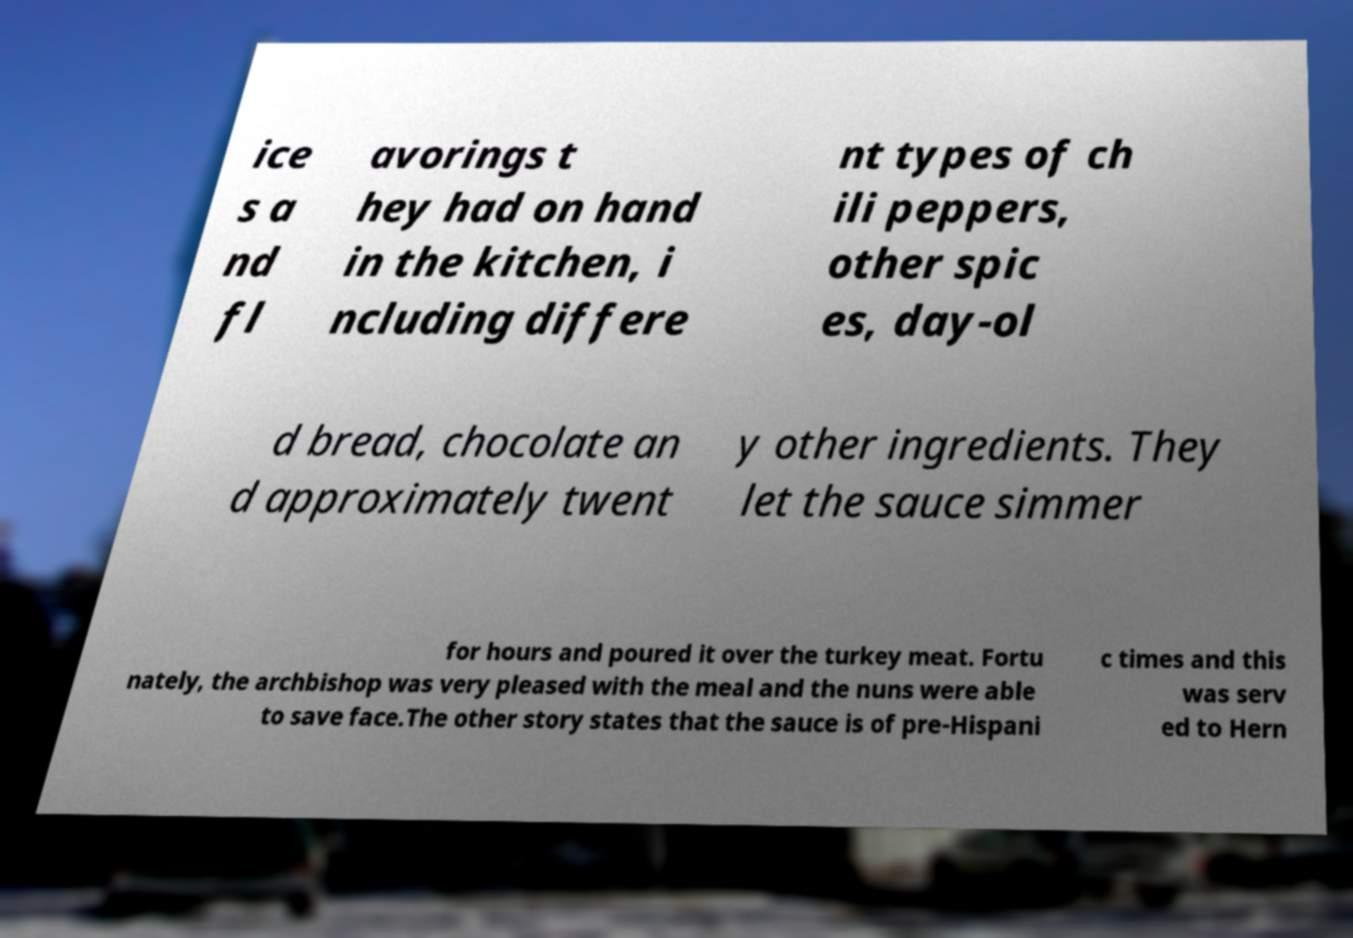There's text embedded in this image that I need extracted. Can you transcribe it verbatim? ice s a nd fl avorings t hey had on hand in the kitchen, i ncluding differe nt types of ch ili peppers, other spic es, day-ol d bread, chocolate an d approximately twent y other ingredients. They let the sauce simmer for hours and poured it over the turkey meat. Fortu nately, the archbishop was very pleased with the meal and the nuns were able to save face.The other story states that the sauce is of pre-Hispani c times and this was serv ed to Hern 